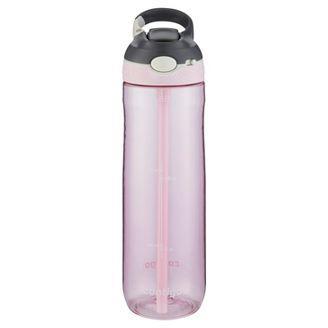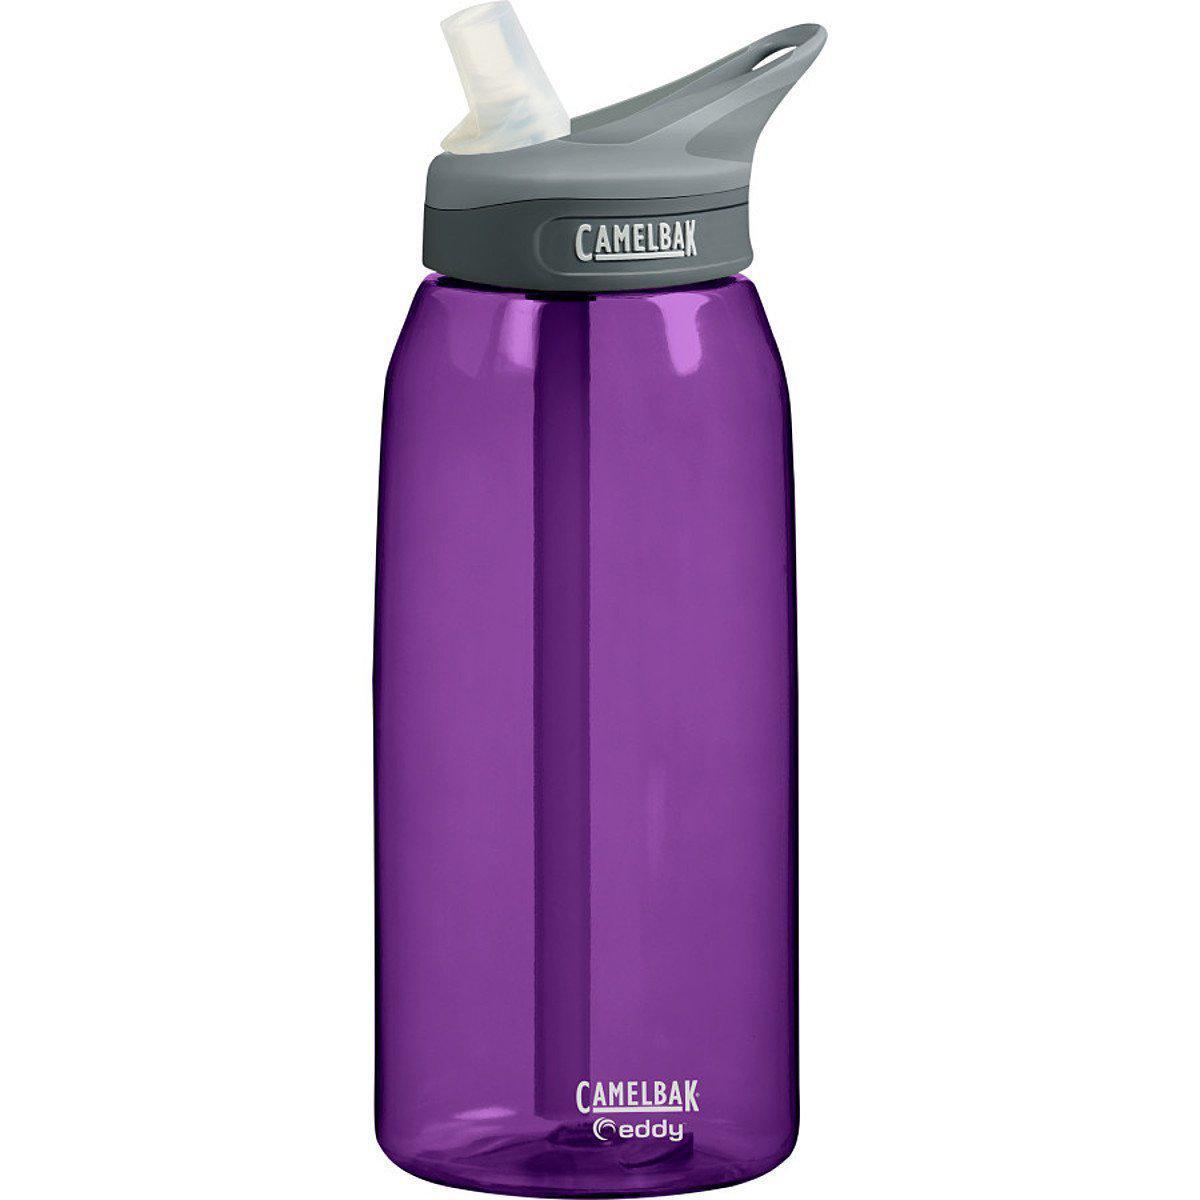The first image is the image on the left, the second image is the image on the right. Evaluate the accuracy of this statement regarding the images: "Out of the two bottles, one is blue.". Is it true? Answer yes or no. No. The first image is the image on the left, the second image is the image on the right. Analyze the images presented: Is the assertion "An image contains exactly one vivid purple upright water bottle." valid? Answer yes or no. Yes. 